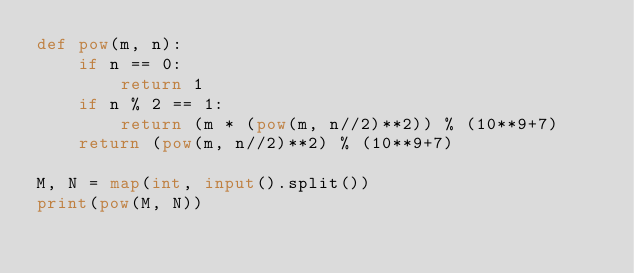<code> <loc_0><loc_0><loc_500><loc_500><_Python_>def pow(m, n):
	if n == 0:
		return 1
	if n % 2 == 1:
		return (m * (pow(m, n//2)**2)) % (10**9+7)
	return (pow(m, n//2)**2) % (10**9+7)

M, N = map(int, input().split())
print(pow(M, N))
</code> 